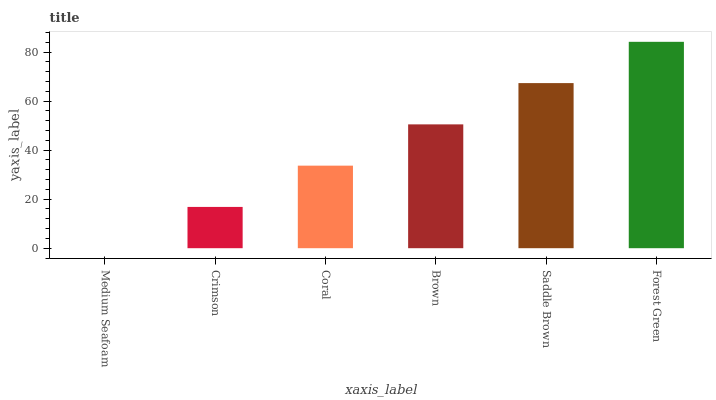Is Medium Seafoam the minimum?
Answer yes or no. Yes. Is Forest Green the maximum?
Answer yes or no. Yes. Is Crimson the minimum?
Answer yes or no. No. Is Crimson the maximum?
Answer yes or no. No. Is Crimson greater than Medium Seafoam?
Answer yes or no. Yes. Is Medium Seafoam less than Crimson?
Answer yes or no. Yes. Is Medium Seafoam greater than Crimson?
Answer yes or no. No. Is Crimson less than Medium Seafoam?
Answer yes or no. No. Is Brown the high median?
Answer yes or no. Yes. Is Coral the low median?
Answer yes or no. Yes. Is Saddle Brown the high median?
Answer yes or no. No. Is Medium Seafoam the low median?
Answer yes or no. No. 